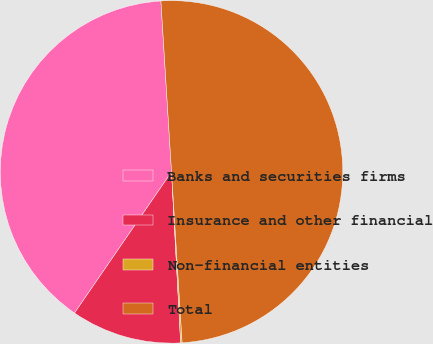<chart> <loc_0><loc_0><loc_500><loc_500><pie_chart><fcel>Banks and securities firms<fcel>Insurance and other financial<fcel>Non-financial entities<fcel>Total<nl><fcel>39.43%<fcel>10.43%<fcel>0.14%<fcel>50.0%<nl></chart> 